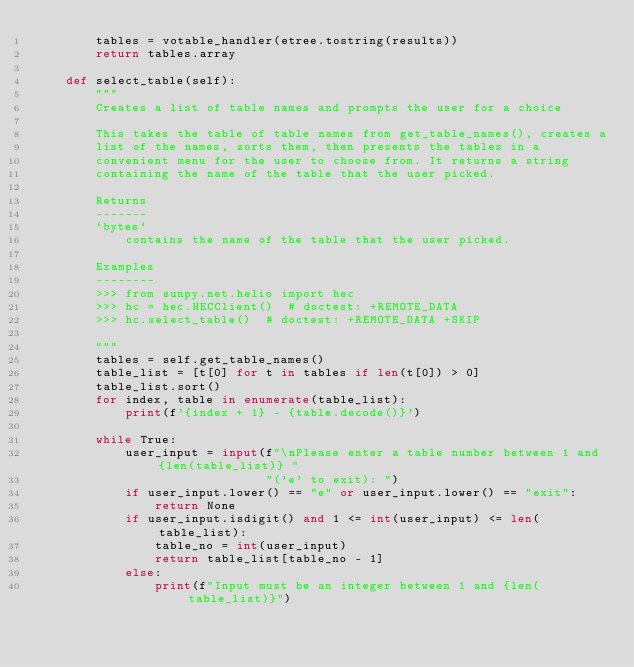<code> <loc_0><loc_0><loc_500><loc_500><_Python_>        tables = votable_handler(etree.tostring(results))
        return tables.array

    def select_table(self):
        """
        Creates a list of table names and prompts the user for a choice

        This takes the table of table names from get_table_names(), creates a
        list of the names, sorts them, then presents the tables in a
        convenient menu for the user to choose from. It returns a string
        containing the name of the table that the user picked.

        Returns
        -------
        `bytes`
            contains the name of the table that the user picked.

        Examples
        --------
        >>> from sunpy.net.helio import hec
        >>> hc = hec.HECClient()  # doctest: +REMOTE_DATA
        >>> hc.select_table()  # doctest: +REMOTE_DATA +SKIP

        """
        tables = self.get_table_names()
        table_list = [t[0] for t in tables if len(t[0]) > 0]
        table_list.sort()
        for index, table in enumerate(table_list):
            print(f'{index + 1} - {table.decode()}')

        while True:
            user_input = input(f"\nPlease enter a table number between 1 and {len(table_list)} "
                               "('e' to exit): ")
            if user_input.lower() == "e" or user_input.lower() == "exit":
                return None
            if user_input.isdigit() and 1 <= int(user_input) <= len(table_list):
                table_no = int(user_input)
                return table_list[table_no - 1]
            else:
                print(f"Input must be an integer between 1 and {len(table_list)}")
</code> 